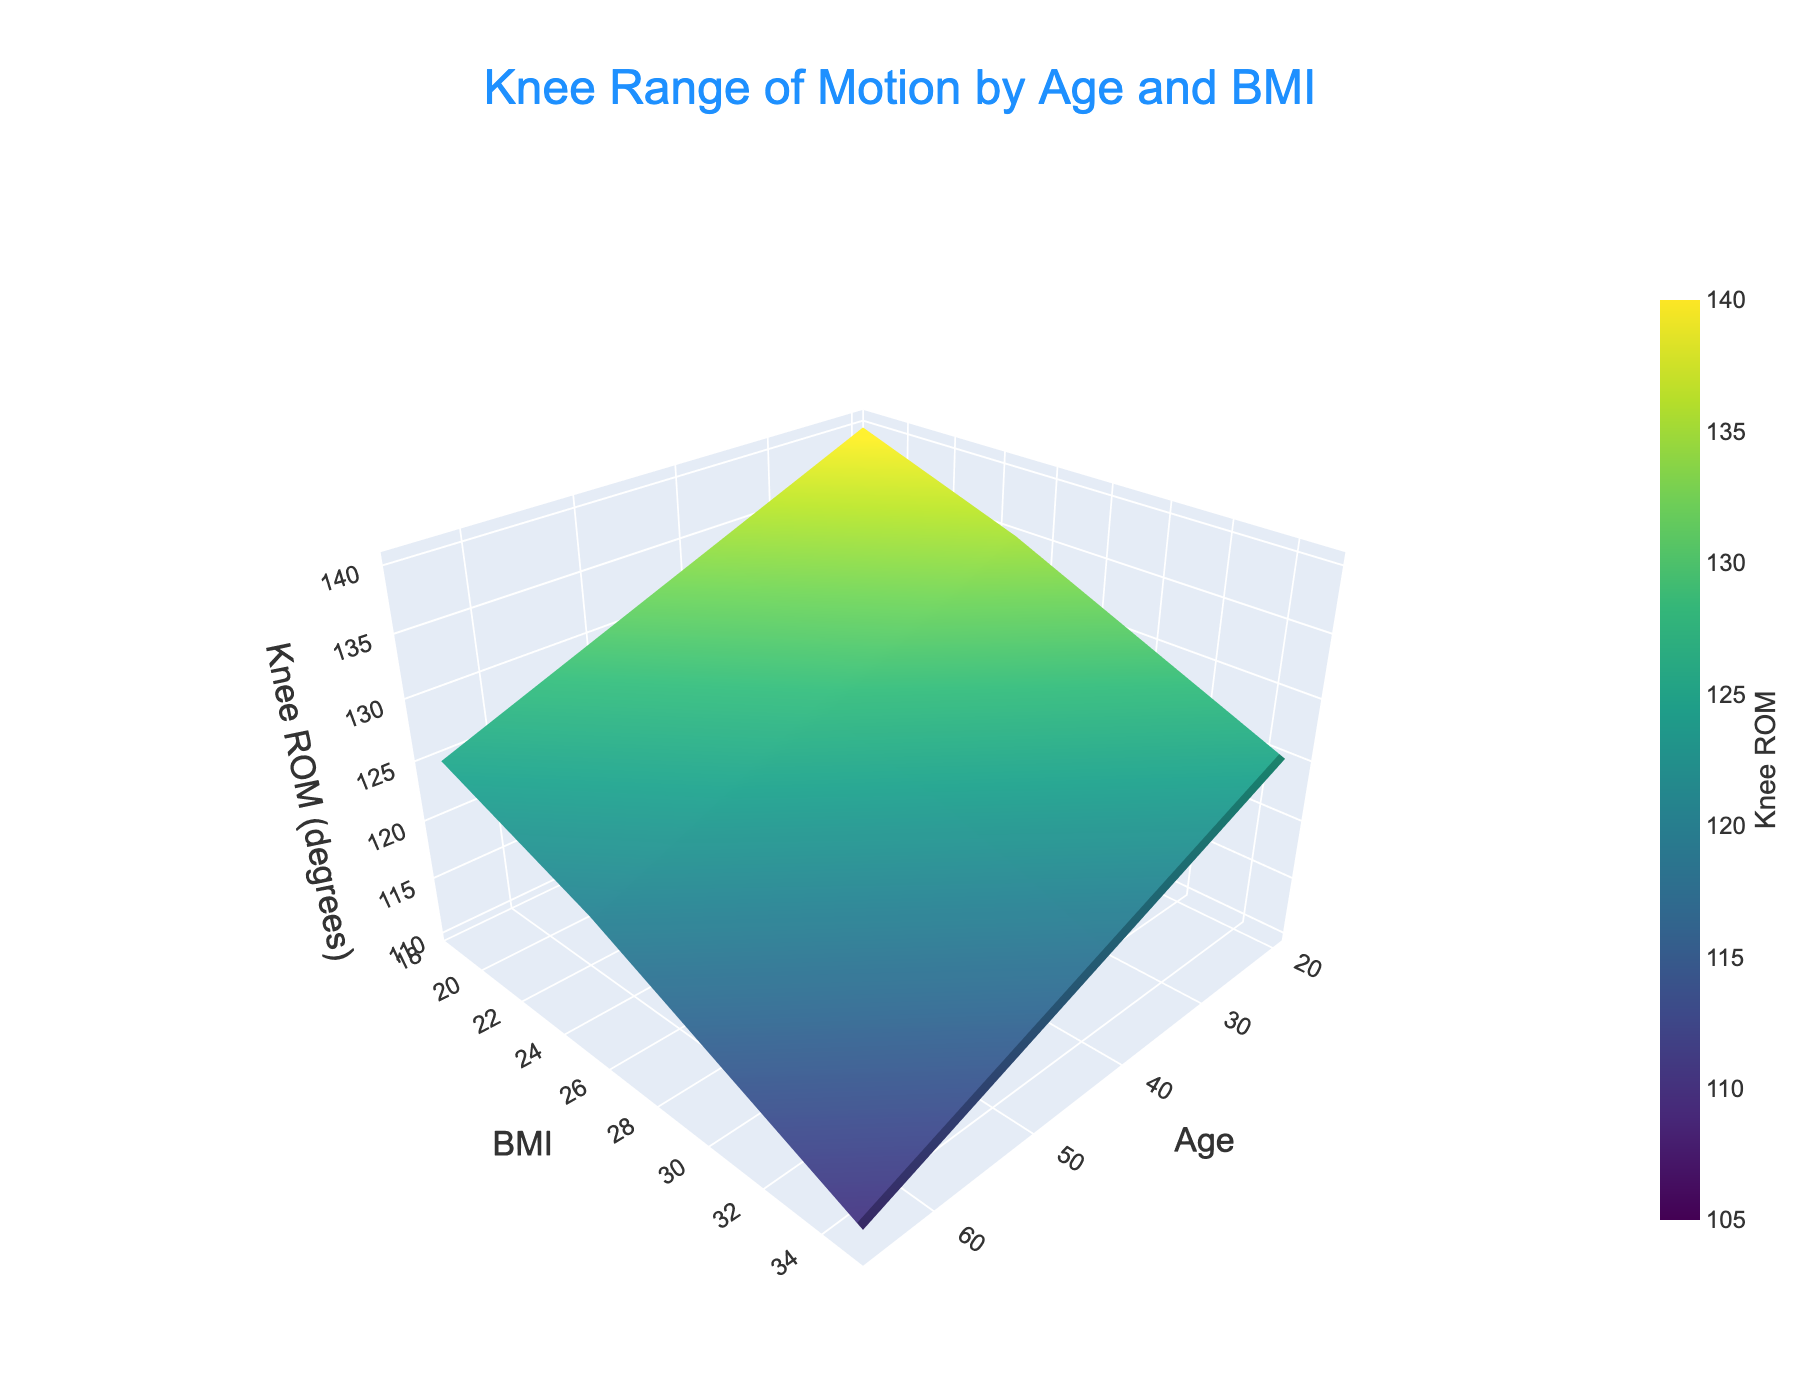What is the title of the plot? The title is typically displayed at the top of the plot, and it gives an overview of what the plot is about. Here, it should be located in the center of the top margin as specified in the layout configuration.
Answer: Knee Range of Motion by Age and BMI What is the range of the x-axis labeled "Age"? The x-axis title "Age" indicates that it represents the different age groups in the dataset. Checking the extremes on the x-axis will tell us the minimum and maximum ages covered in the plot.
Answer: 20 to 80 Which BMI category shows the highest knee range of motion (ROM) for any age group? By identifying the highest peak on the surface plot and tracing it back to its corresponding BMI value on the y-axis, we can determine which BMI category has the highest knee ROM.
Answer: 18.5 How does the knee range of motion vary with age for the BMI of 25? To answer this, observe the slice of the plot at BMI = 25 and note how the knee ROM values change as you move along the age axis from 20 to 80.
Answer: It decreases as age increases What is the knee ROM for age 50 and BMI 30? Locate the point on the surface plot where age is 50 and BMI is 30, and note the corresponding knee ROM value.
Answer: 120 degrees What's the difference in knee ROM between age 20 and age 80 for BMI 35? Find the knee ROM values for BMI 35 at ages 20 and 80, then calculate the difference between these two values. The ROM at age 20 is 125 degrees, and at age 80 is 105 degrees.
Answer: 20 degrees At what age does the knee ROM drop below 120 degrees for a BMI of 18.5? Trace the knee ROM values for BMI 18.5 along the age axis and identify the age at which it first falls below 120 degrees.
Answer: 80 Is there a BMI category where knee ROM is consistently below 120 degrees across all age groups? By examining each BMI category's ROM across all ages, check if there is any category where all the ROM values are below 120 degrees.
Answer: 35 How does the change in knee ROM from age 35 to 65 compare between BMI 18.5 and BMI 30? Calculate the change in knee ROM from age 35 to 65 for both BMI 18.5 and 30. For BMI 18.5: 135 to 125 (change: -10), for BMI 30: 125 to 115 (change: -10). Compare these two changes.
Answer: They are the same Which combination of age and BMI shows the minimum knee ROM? Identify the lowest point on the 3D surface plot and trace it back to the corresponding age and BMI values on the axes.
Answer: Age 80, BMI 35 